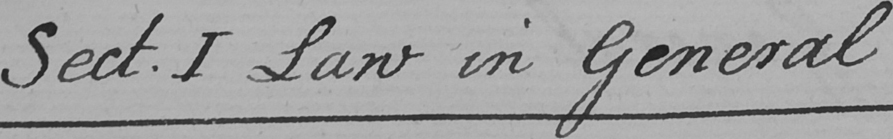What text is written in this handwritten line? Sect . I Law in General 